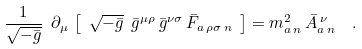<formula> <loc_0><loc_0><loc_500><loc_500>\frac { 1 } { \sqrt { - \bar { g } } } \ \partial _ { \mu } \, \left [ \ \sqrt { - \bar { g } } \ \bar { g } ^ { \mu \rho } \, \bar { g } ^ { \nu \sigma } \, \bar { F } _ { a \, \rho \sigma \, n } \ \right ] = m _ { a \, n } ^ { 2 } \, \bar { A } _ { a \, n } ^ { \, \nu } \ \ .</formula> 